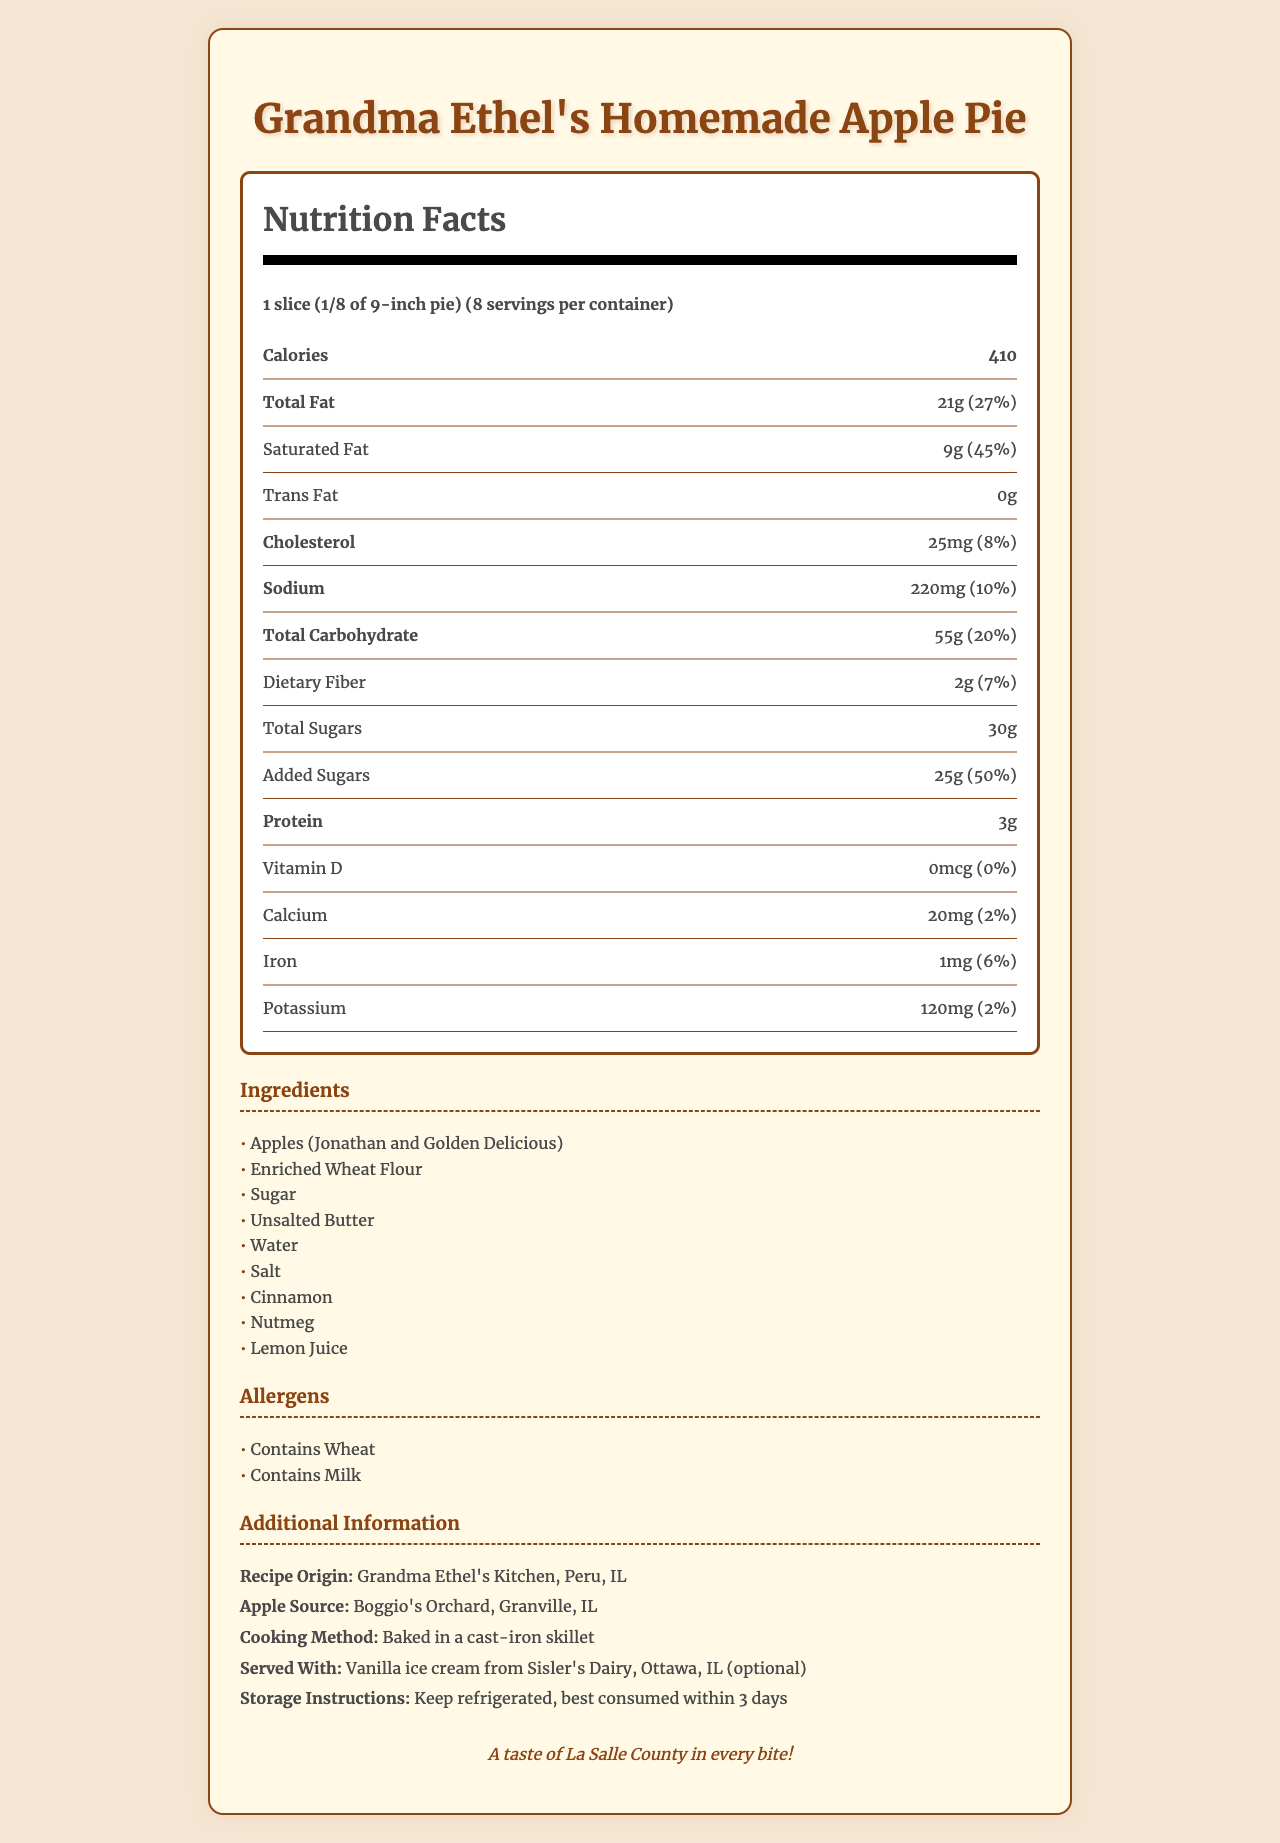What is the serving size? The serving size specified in the document is "1 slice (1/8 of 9-inch pie)".
Answer: 1 slice (1/8 of 9-inch pie) How many calories are in one slice of the pie? The document states that each serving of the pie contains 410 calories.
Answer: 410 What is the total fat content in one serving? According to the nutrition label, each slice contains 21g of total fat.
Answer: 21g What is the source of the apples used in the pie? The additional information section mentions that the apples are sourced from Boggio's Orchard in Granville, IL.
Answer: Boggio's Orchard, Granville, IL How much added sugar is there in one slice? The document specifies that each serving contains 25g of added sugars.
Answer: 25g How much dietary fiber is in each serving? The dietary fiber content for each slice of the pie is listed as 2g.
Answer: 2g How long does the pie stay fresh? The storage instructions indicate that the pie is best consumed within 3 days when refrigerated.
Answer: Best consumed within 3 days True or False: The apple pie contains peanuts. There is no mention of peanuts in the ingredients or allergens list.
Answer: False Which ingredient is not in the pie? A. Apples B. Cinnamon C. Chocolate D. Lemon Juice Chocolate is not listed among the ingredients for the pie.
Answer: C. Chocolate Which of the following nutrients has the highest daily value percentage? I. Saturated Fat II. Sodium III. Iron IV. Dietary Fiber The daily value percentage for saturated fat is 45%, which is the highest among the nutrients listed.
Answer: I. Saturated Fat Where did the recipe for the pie originate? The document mentions that the recipe originated in Grandma Ethel's Kitchen in Peru, IL.
Answer: Grandma Ethel's Kitchen, Peru, IL How should the pie be stored for best results? The document advises refrigerating the pie for best results.
Answer: Keep refrigerated Is the apple pie gluten-free? The allergens section states that the pie contains wheat.
Answer: No, it contains wheat Describe the main idea of the document. The document details the nutritional content for a slice of the pie, lists the ingredients and allergens, and provides additional information about the recipe origin, apple source, cooking method, suggested servings, and storage instructions.
Answer: The document provides the nutrition facts and additional information for Grandma Ethel's homemade apple pie, including serving size, ingredients, nutritional content, and storage instructions. Does the document mention the cost of the pie? There is no mention of the cost of the pie in the document.
Answer: Cannot be determined 